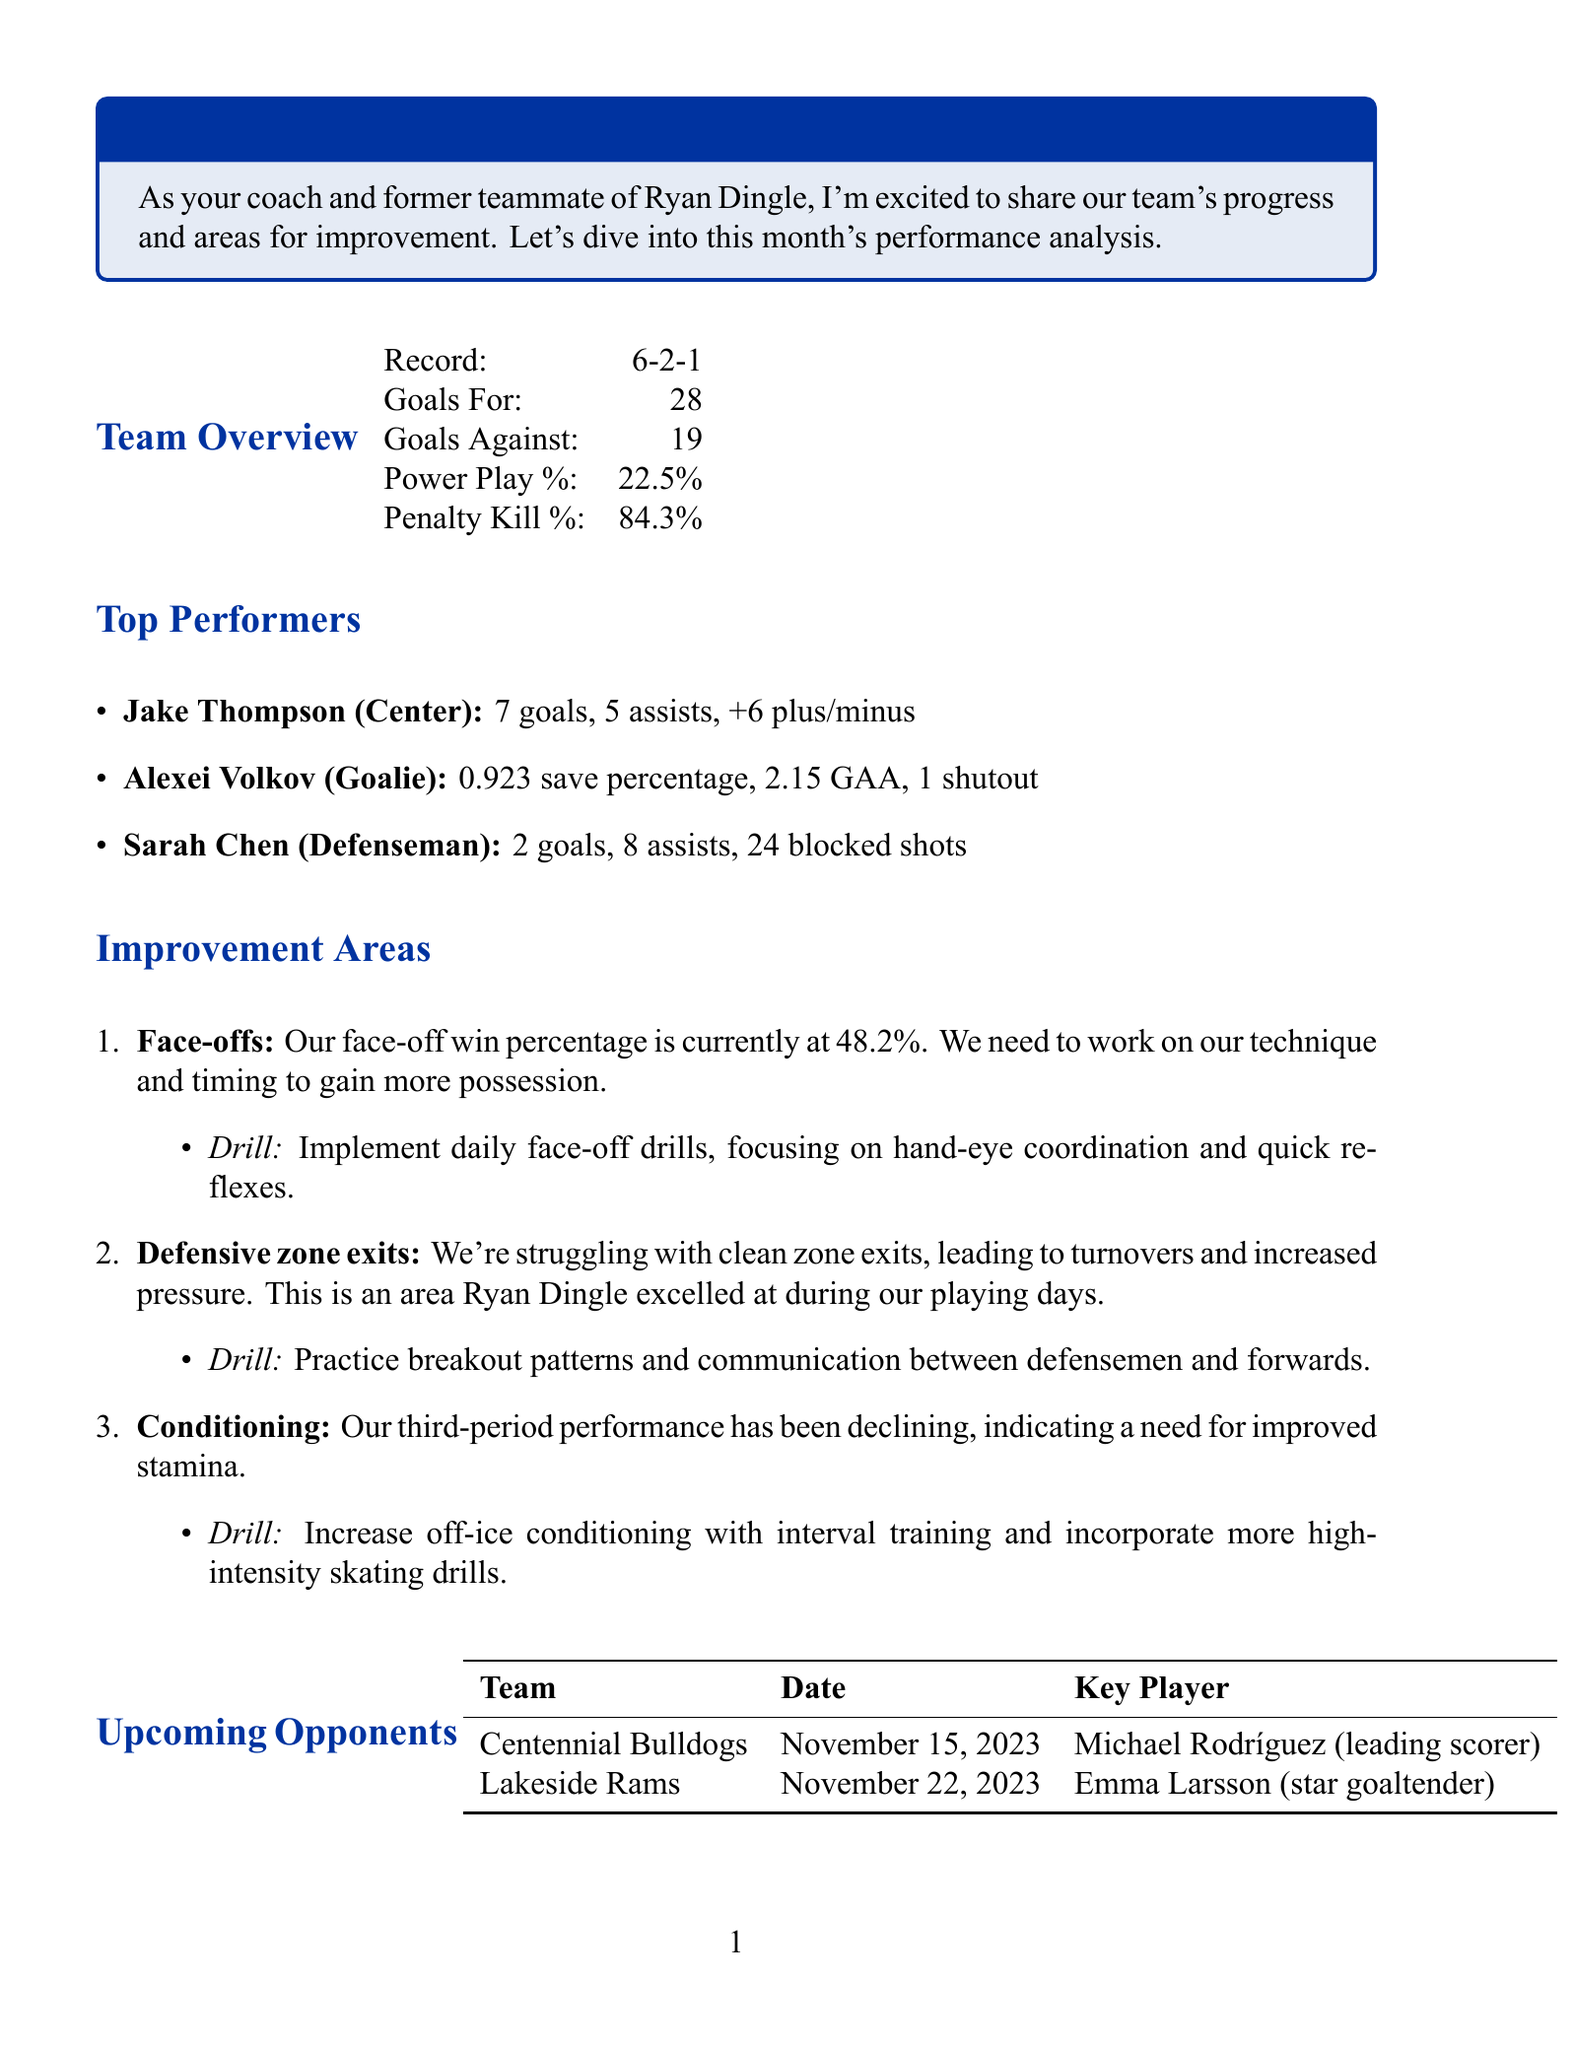What is the team's record? The team's performance record is stated in the team overview section of the document.
Answer: 6-2-1 Who is the top scorer for the team? The document lists Jake Thompson as the top performer with the most goals in the top performers section.
Answer: Jake Thompson What is the power play percentage? The power play percentage is provided in the team overview section of the document.
Answer: 22.5% What area needs improvement related to face-offs? The improvement areas section discusses the face-off win percentage specifically.
Answer: Face-offs What drill is suggested for improving defensive zone exits? The drill suggestion for defensive zone exits is mentioned in the improvement areas section.
Answer: Practice breakout patterns Who is the key player for the Centennial Bulldogs? The upcoming opponents section names the key player for the Centennial Bulldogs.
Answer: Michael Rodríguez What was Sarah Chen's number of blocked shots? The document provides statistics for Sarah Chen in the top performers section, including blocked shots.
Answer: 24 How many goals against does the team have? The goals against statistic is included in the team overview section.
Answer: 19 What is the key area for improvement related to third-period performance? The improvement areas section suggests that conditioning is important for better third-period performance.
Answer: Conditioning 